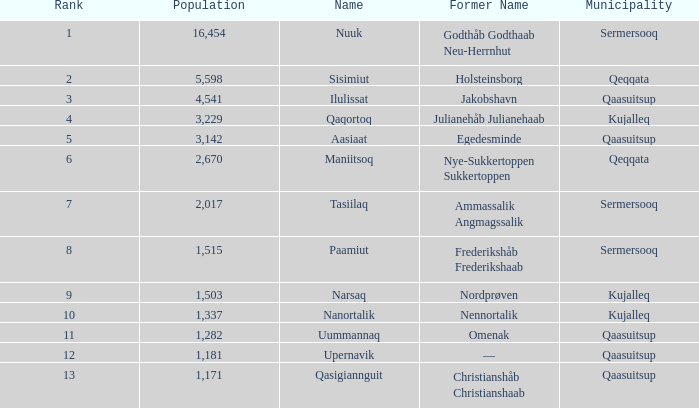Who used to be known as nordprøven? Narsaq. 